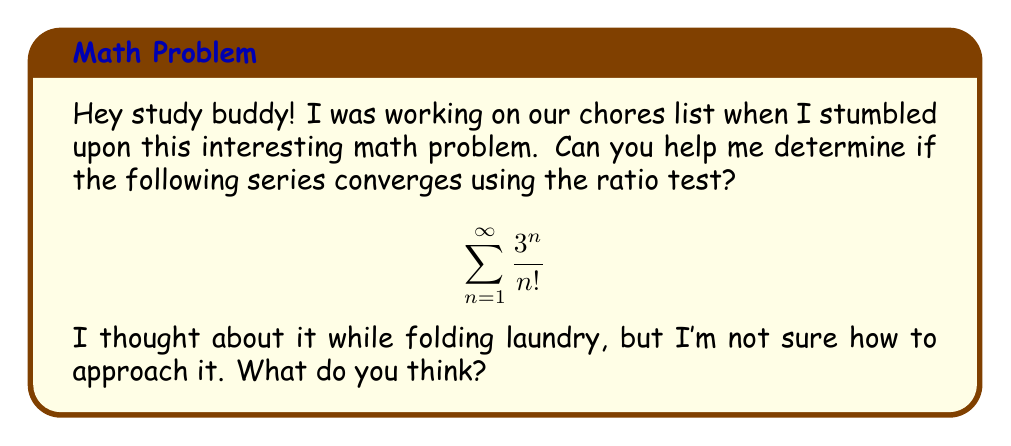Could you help me with this problem? Sure thing! Let's tackle this problem step by step using the ratio test:

1) First, let's recall the ratio test. For a series $\sum_{n=1}^{\infty} a_n$, we compute:

   $$L = \lim_{n \to \infty} \left|\frac{a_{n+1}}{a_n}\right|$$

   If $L < 1$, the series converges. If $L > 1$, the series diverges. If $L = 1$, the test is inconclusive.

2) In our case, $a_n = \frac{3^n}{n!}$. Let's find $a_{n+1}$:

   $$a_{n+1} = \frac{3^{n+1}}{(n+1)!}$$

3) Now, let's form the ratio $\frac{a_{n+1}}{a_n}$:

   $$\frac{a_{n+1}}{a_n} = \frac{\frac{3^{n+1}}{(n+1)!}}{\frac{3^n}{n!}}$$

4) Simplify:
   
   $$\frac{a_{n+1}}{a_n} = \frac{3^{n+1}}{(n+1)!} \cdot \frac{n!}{3^n} = \frac{3^{n+1}}{3^n} \cdot \frac{n!}{(n+1)!} = 3 \cdot \frac{1}{n+1}$$

5) Now, let's take the limit as $n$ approaches infinity:

   $$L = \lim_{n \to \infty} \left|\frac{a_{n+1}}{a_n}\right| = \lim_{n \to \infty} \left|3 \cdot \frac{1}{n+1}\right| = 3 \cdot \lim_{n \to \infty} \frac{1}{n+1} = 3 \cdot 0 = 0$$

6) Since $L = 0 < 1$, by the ratio test, the series converges.
Answer: The series converges. 